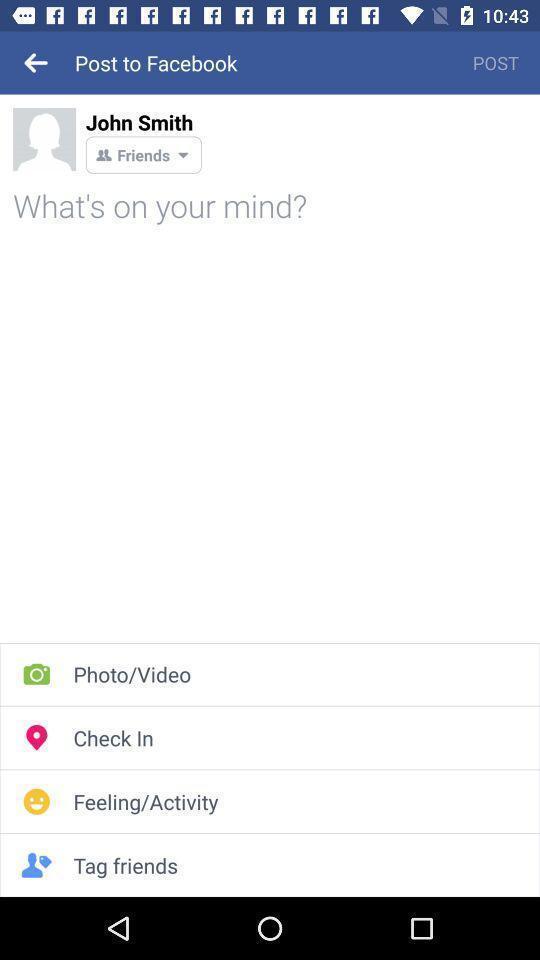Provide a textual representation of this image. Profile page of a social application with multiple features. 